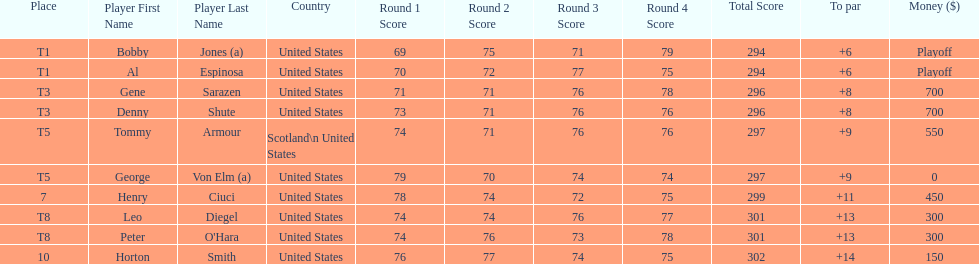Gene sarazen and denny shute are both from which country? United States. 